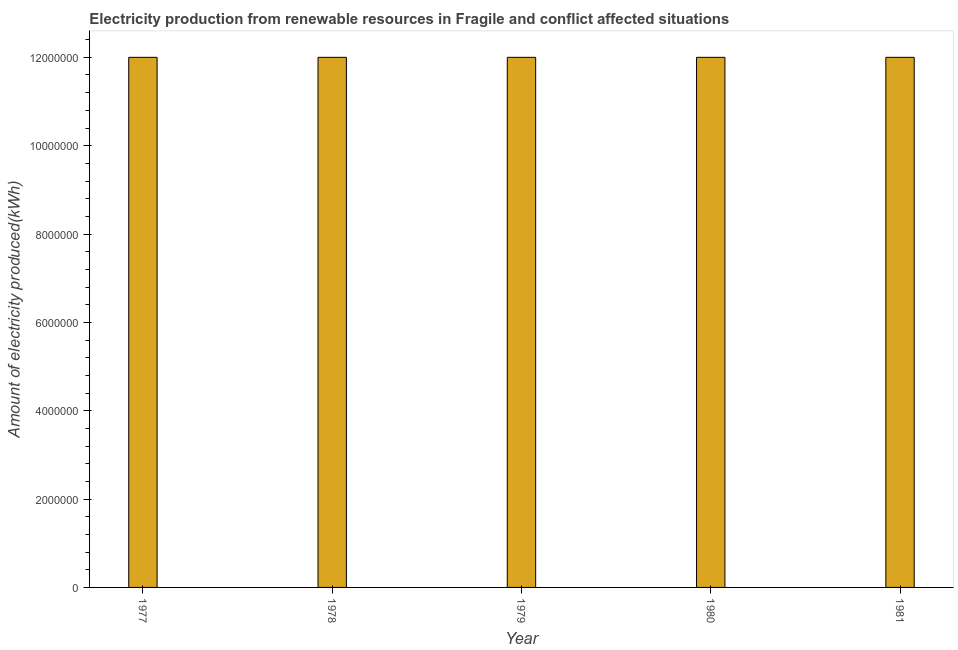Does the graph contain any zero values?
Offer a terse response. No. Does the graph contain grids?
Offer a terse response. No. What is the title of the graph?
Provide a short and direct response. Electricity production from renewable resources in Fragile and conflict affected situations. What is the label or title of the Y-axis?
Your response must be concise. Amount of electricity produced(kWh). In which year was the amount of electricity produced maximum?
Make the answer very short. 1977. In which year was the amount of electricity produced minimum?
Make the answer very short. 1977. What is the sum of the amount of electricity produced?
Offer a very short reply. 6.00e+07. What is the average amount of electricity produced per year?
Give a very brief answer. 1.20e+07. In how many years, is the amount of electricity produced greater than 4800000 kWh?
Offer a very short reply. 5. Do a majority of the years between 1980 and 1978 (inclusive) have amount of electricity produced greater than 12000000 kWh?
Your answer should be compact. Yes. Is the amount of electricity produced in 1977 less than that in 1980?
Offer a very short reply. No. Is the difference between the amount of electricity produced in 1977 and 1980 greater than the difference between any two years?
Provide a succinct answer. Yes. What is the difference between the highest and the lowest amount of electricity produced?
Give a very brief answer. 0. How many bars are there?
Your answer should be compact. 5. Are all the bars in the graph horizontal?
Keep it short and to the point. No. How many years are there in the graph?
Offer a terse response. 5. What is the difference between two consecutive major ticks on the Y-axis?
Make the answer very short. 2.00e+06. Are the values on the major ticks of Y-axis written in scientific E-notation?
Keep it short and to the point. No. What is the Amount of electricity produced(kWh) in 1977?
Keep it short and to the point. 1.20e+07. What is the Amount of electricity produced(kWh) of 1978?
Keep it short and to the point. 1.20e+07. What is the Amount of electricity produced(kWh) of 1980?
Ensure brevity in your answer.  1.20e+07. What is the difference between the Amount of electricity produced(kWh) in 1977 and 1978?
Provide a succinct answer. 0. What is the difference between the Amount of electricity produced(kWh) in 1977 and 1979?
Give a very brief answer. 0. What is the difference between the Amount of electricity produced(kWh) in 1977 and 1980?
Your answer should be compact. 0. What is the difference between the Amount of electricity produced(kWh) in 1977 and 1981?
Your response must be concise. 0. What is the difference between the Amount of electricity produced(kWh) in 1978 and 1979?
Keep it short and to the point. 0. What is the difference between the Amount of electricity produced(kWh) in 1978 and 1980?
Offer a very short reply. 0. What is the difference between the Amount of electricity produced(kWh) in 1979 and 1980?
Your answer should be compact. 0. What is the difference between the Amount of electricity produced(kWh) in 1979 and 1981?
Give a very brief answer. 0. What is the ratio of the Amount of electricity produced(kWh) in 1977 to that in 1978?
Ensure brevity in your answer.  1. What is the ratio of the Amount of electricity produced(kWh) in 1977 to that in 1981?
Your response must be concise. 1. What is the ratio of the Amount of electricity produced(kWh) in 1978 to that in 1979?
Your response must be concise. 1. What is the ratio of the Amount of electricity produced(kWh) in 1978 to that in 1980?
Your response must be concise. 1. What is the ratio of the Amount of electricity produced(kWh) in 1978 to that in 1981?
Offer a terse response. 1. What is the ratio of the Amount of electricity produced(kWh) in 1979 to that in 1981?
Ensure brevity in your answer.  1. What is the ratio of the Amount of electricity produced(kWh) in 1980 to that in 1981?
Provide a short and direct response. 1. 